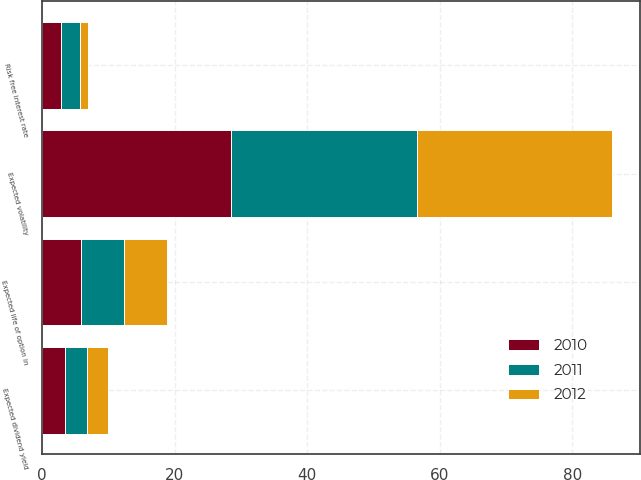<chart> <loc_0><loc_0><loc_500><loc_500><stacked_bar_chart><ecel><fcel>Risk free interest rate<fcel>Expected life of option in<fcel>Expected dividend yield<fcel>Expected volatility<nl><fcel>2012<fcel>1.3<fcel>6.5<fcel>3.3<fcel>29.4<nl><fcel>2011<fcel>2.9<fcel>6.4<fcel>3.3<fcel>28<nl><fcel>2010<fcel>2.8<fcel>5.9<fcel>3.4<fcel>28.5<nl></chart> 